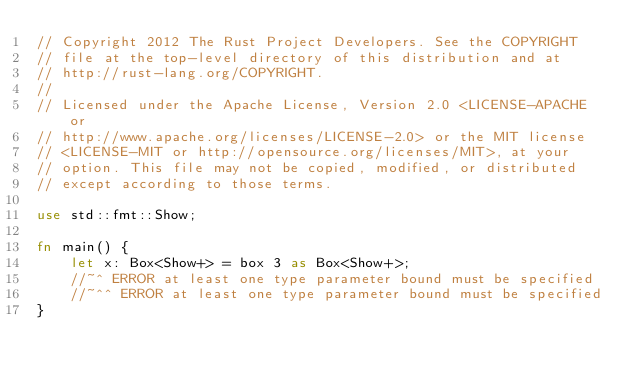Convert code to text. <code><loc_0><loc_0><loc_500><loc_500><_Rust_>// Copyright 2012 The Rust Project Developers. See the COPYRIGHT
// file at the top-level directory of this distribution and at
// http://rust-lang.org/COPYRIGHT.
//
// Licensed under the Apache License, Version 2.0 <LICENSE-APACHE or
// http://www.apache.org/licenses/LICENSE-2.0> or the MIT license
// <LICENSE-MIT or http://opensource.org/licenses/MIT>, at your
// option. This file may not be copied, modified, or distributed
// except according to those terms.

use std::fmt::Show;

fn main() {
    let x: Box<Show+> = box 3 as Box<Show+>;
    //~^ ERROR at least one type parameter bound must be specified
    //~^^ ERROR at least one type parameter bound must be specified
}

</code> 